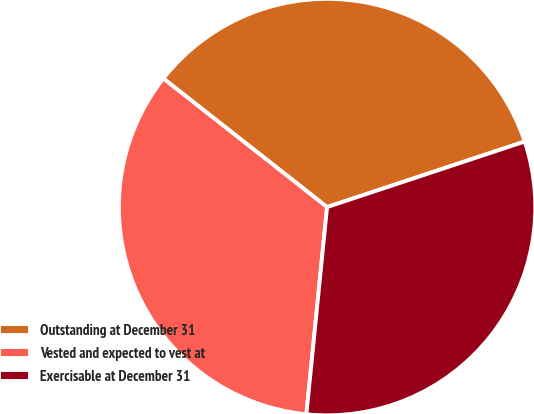<chart> <loc_0><loc_0><loc_500><loc_500><pie_chart><fcel>Outstanding at December 31<fcel>Vested and expected to vest at<fcel>Exercisable at December 31<nl><fcel>34.31%<fcel>34.01%<fcel>31.68%<nl></chart> 